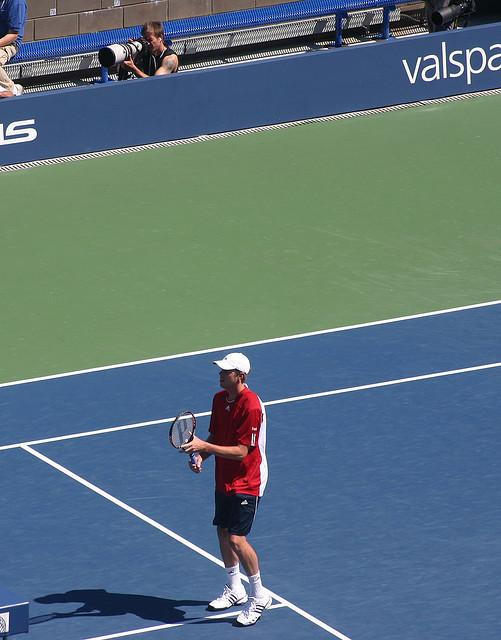How many visible stripes are in his right shoe? Please explain your reasoning. three. The shoes have three stripes each going down the side. 